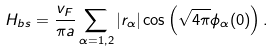Convert formula to latex. <formula><loc_0><loc_0><loc_500><loc_500>H _ { b s } = \frac { v _ { F } } { \pi a } \sum _ { \alpha = 1 , 2 } | r _ { \alpha } | \cos \left ( \sqrt { 4 \pi } \phi _ { \alpha } ( 0 ) \right ) .</formula> 